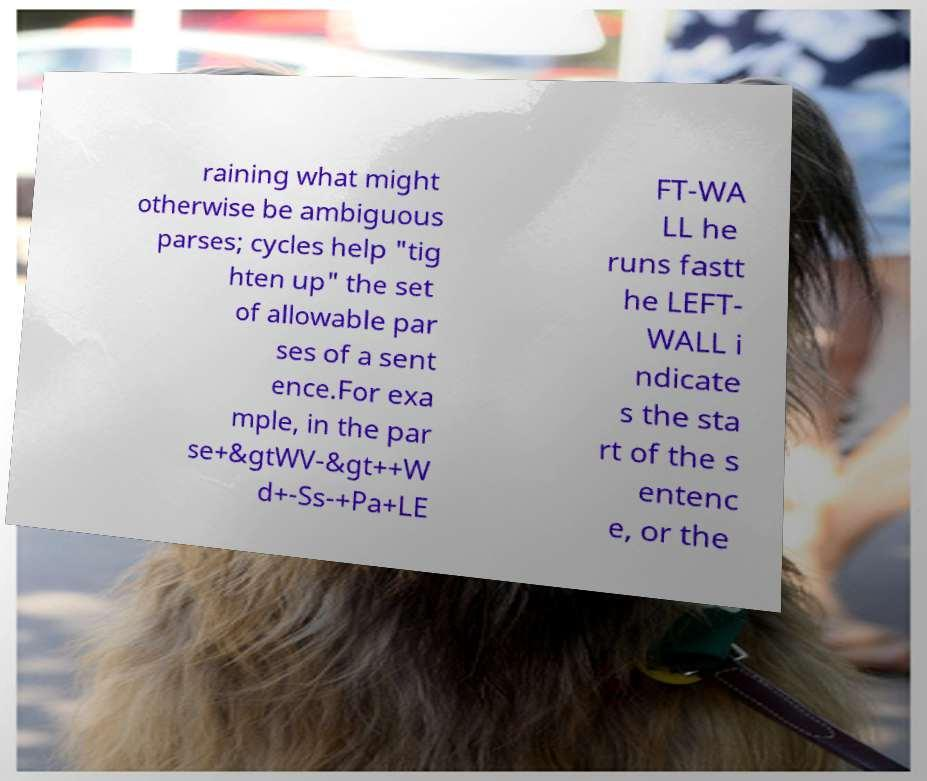Could you extract and type out the text from this image? raining what might otherwise be ambiguous parses; cycles help "tig hten up" the set of allowable par ses of a sent ence.For exa mple, in the par se+&gtWV-&gt++W d+-Ss-+Pa+LE FT-WA LL he runs fastt he LEFT- WALL i ndicate s the sta rt of the s entenc e, or the 